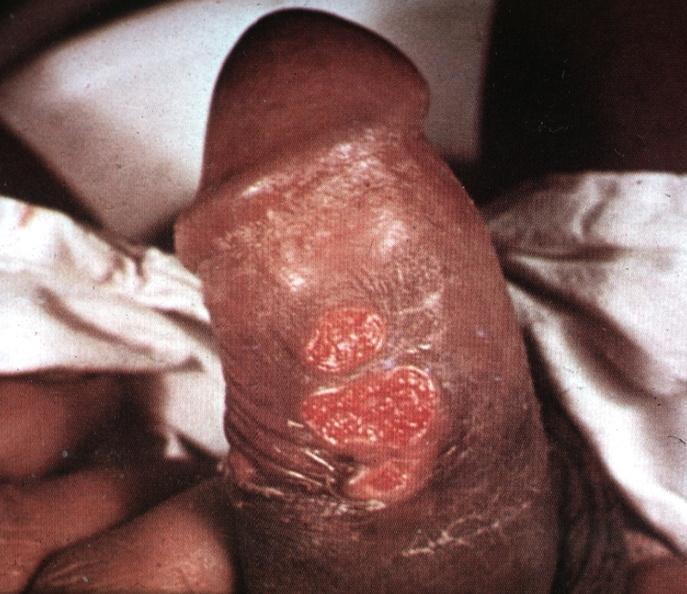s penis present?
Answer the question using a single word or phrase. Yes 